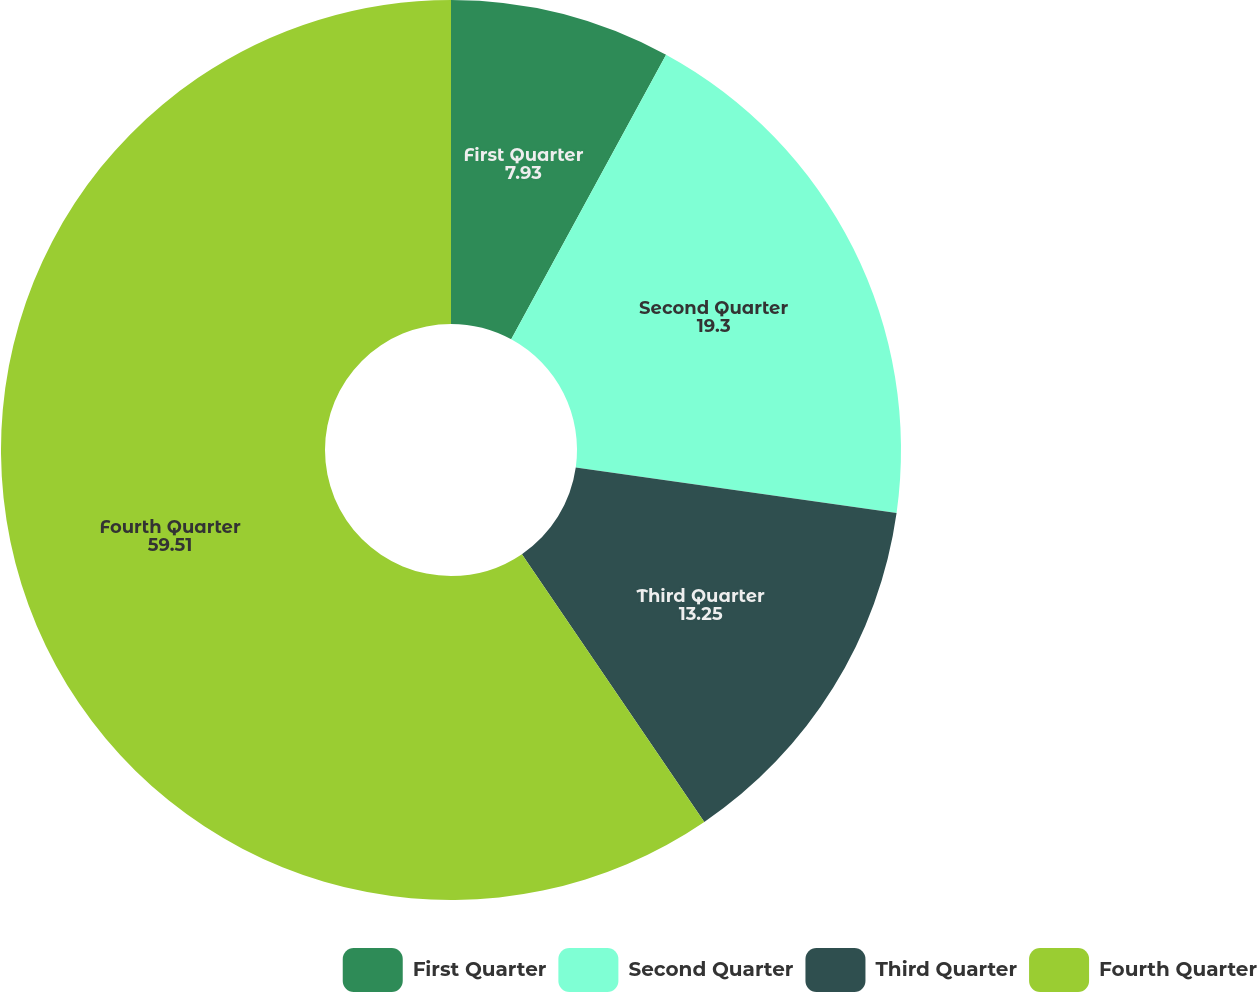Convert chart. <chart><loc_0><loc_0><loc_500><loc_500><pie_chart><fcel>First Quarter<fcel>Second Quarter<fcel>Third Quarter<fcel>Fourth Quarter<nl><fcel>7.93%<fcel>19.3%<fcel>13.25%<fcel>59.51%<nl></chart> 